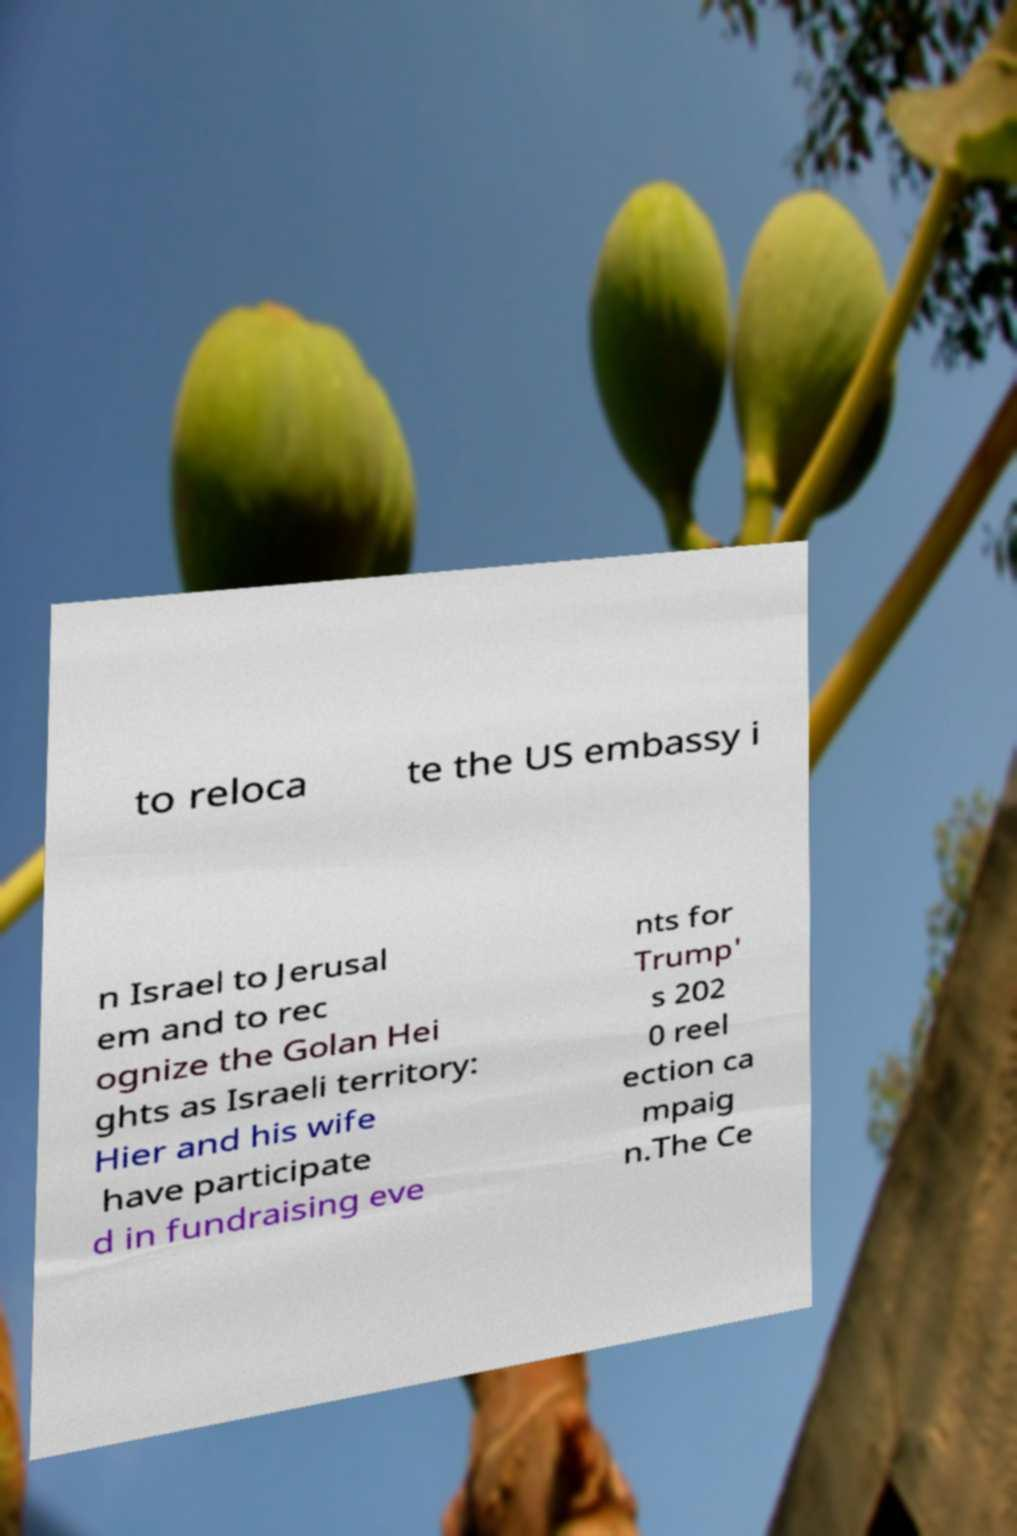What messages or text are displayed in this image? I need them in a readable, typed format. to reloca te the US embassy i n Israel to Jerusal em and to rec ognize the Golan Hei ghts as Israeli territory: Hier and his wife have participate d in fundraising eve nts for Trump' s 202 0 reel ection ca mpaig n.The Ce 